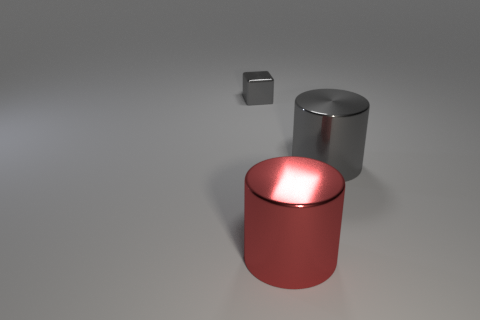Can you describe the lighting in this scene? The lighting in the scene is soft and diffuse, coming from above, which creates gentle shadows and emphasizes the objects' shapes without harsh contrasts. 